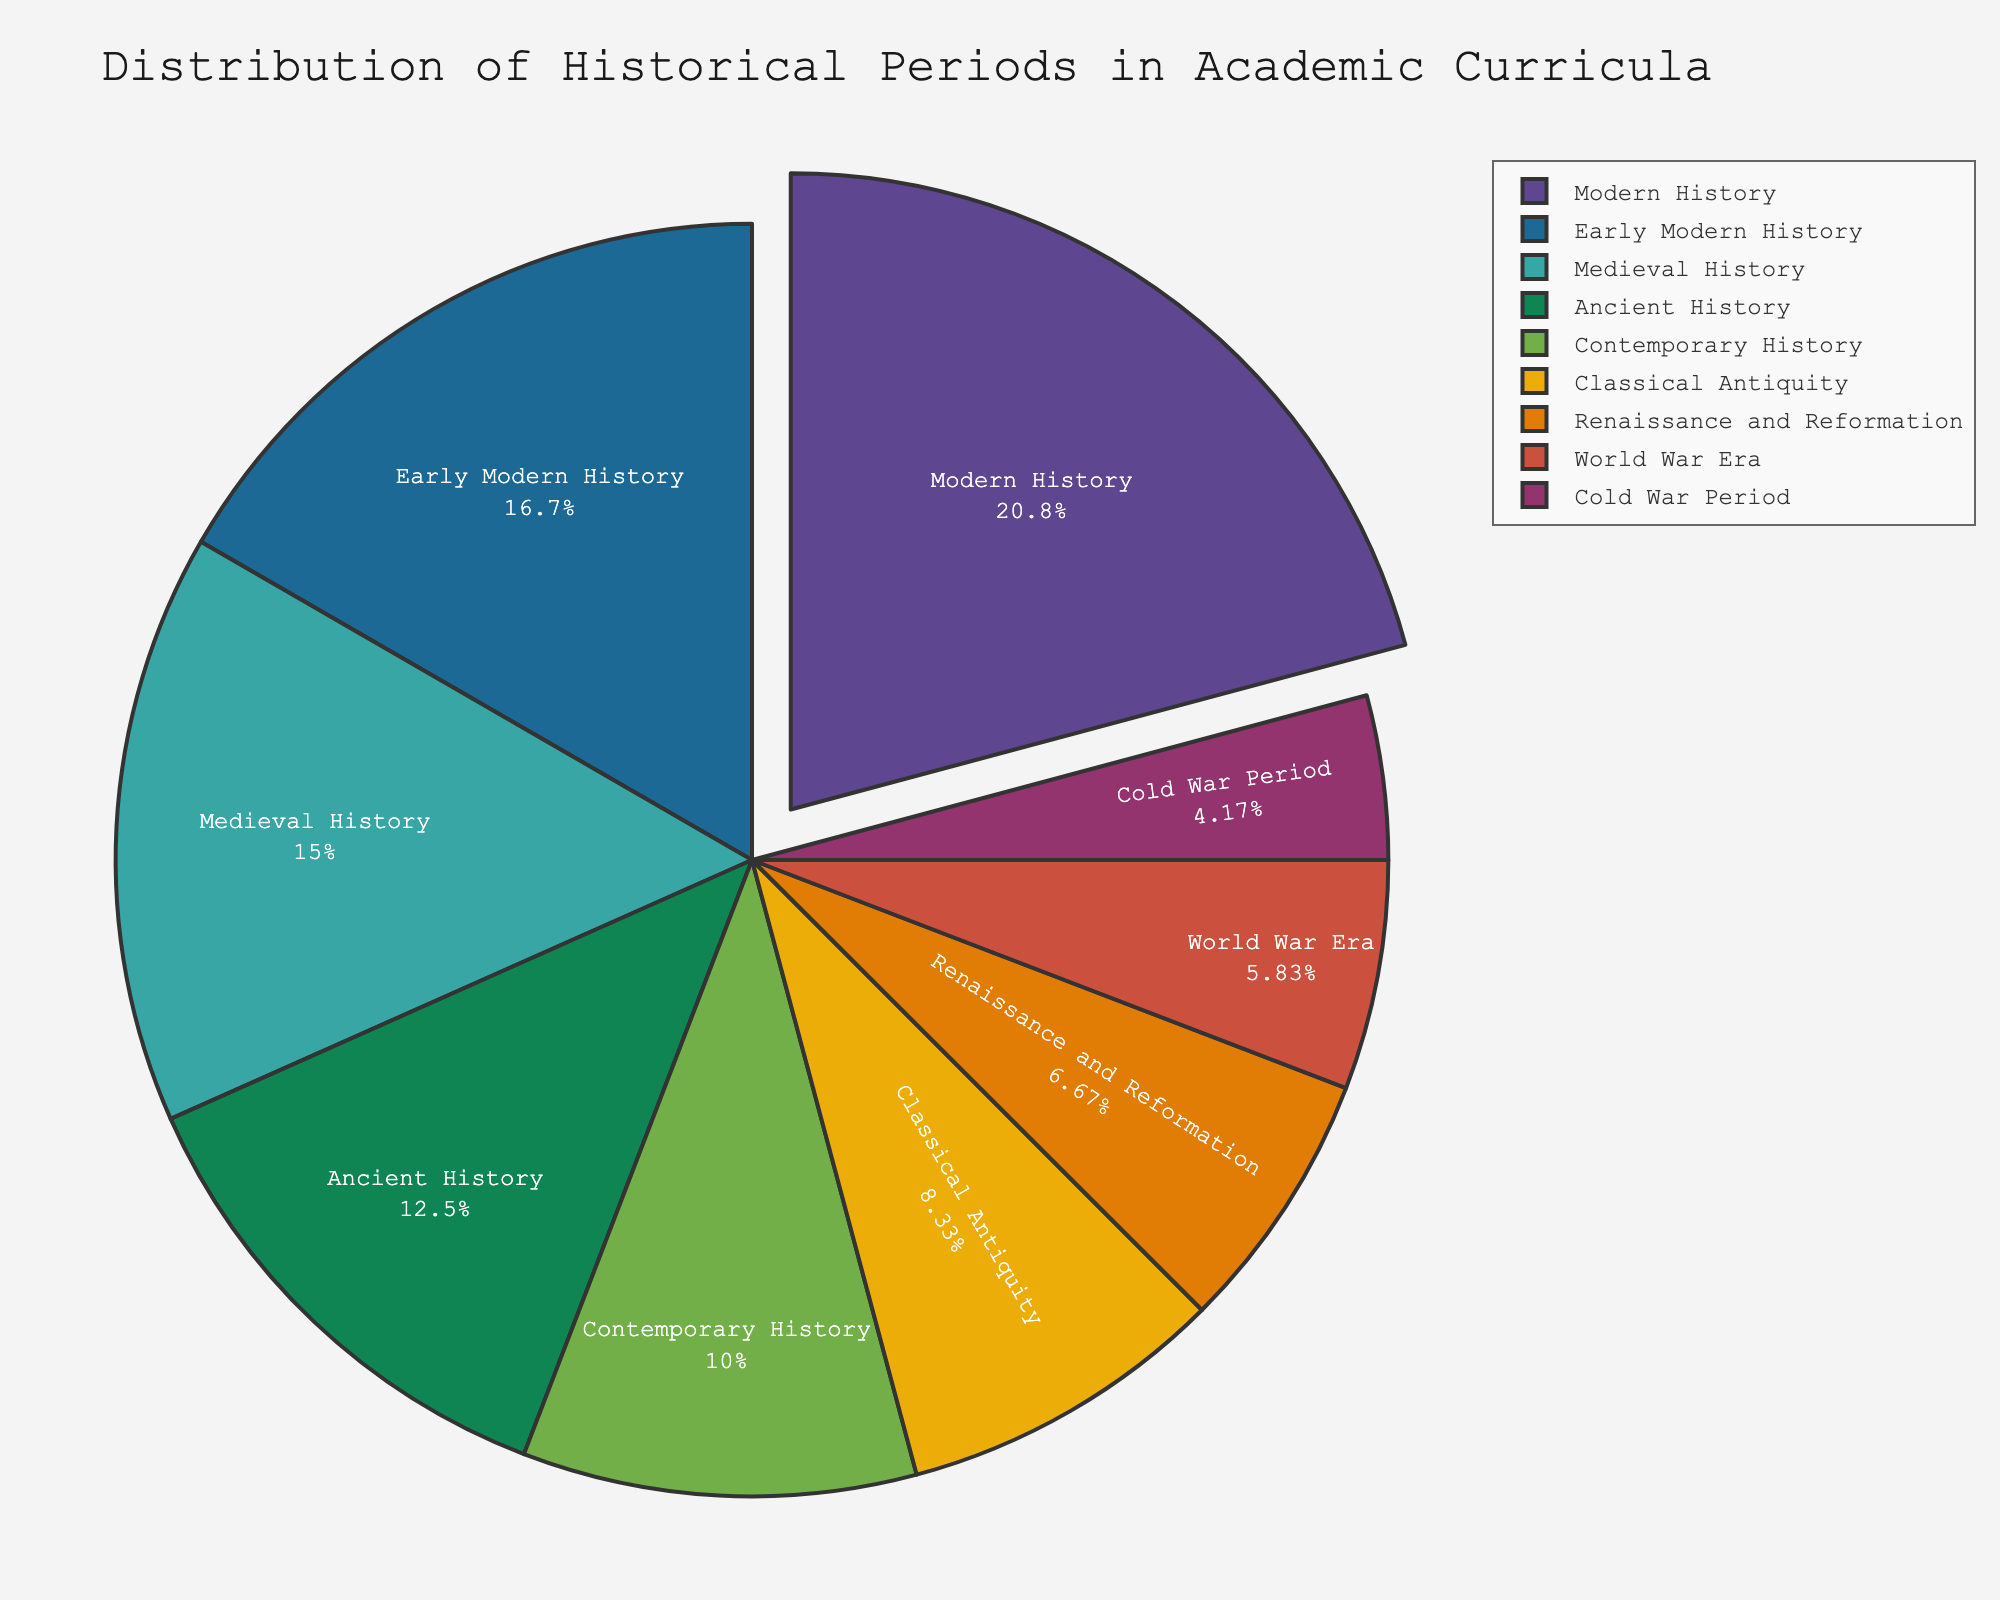What proportion of the historical periods is represented by Modern History? Modern History has a segment in the pie chart labeled with its percentage. Simply look at the label.
Answer: 25% Which historical period represents the smallest proportion in academic curricula, and what is its percentage? Find the smallest segment in the pie chart and refer to the label for its percentage.
Answer: Cold War Period, 5% How much more is the proportion of Ancient History compared to the Renaissance and Reformation? Look at the labels for Ancient History and Renaissance and Reformation to get their percentages and subtract the latter from the former (15% - 8%).
Answer: 7% What is the combined proportion of Medieval History and Early Modern History? Add the percentages of Medieval History and Early Modern History (18% + 20%).
Answer: 38% Which historical periods have a larger proportion than Classical Antiquity? Compare the percentage labels of Classical Antiquity (10%) to other periods. Ancient History (15%), Medieval History (18%), Early Modern History (20%), Modern History (25%), and Contemporary History (12%) have larger proportions.
Answer: Ancient History, Medieval History, Early Modern History, Modern History, Contemporary History How does the proportion of Contemporary History compare to that of Ancient History? Compare the percentage labels of Contemporary History (12%) to Ancient History (15%). Contemporary History is smaller.
Answer: Contemporary History is smaller What is the visual difference between the segment for World War Era and that of Cold War Period in the pie chart? The World War Era segment is slightly larger than the Cold War Period segment as represented by their respective percentages (7% vs. 5%).
Answer: World War Era is larger What is the total proportion represented by Modern History, Contemporary History, and the World War Era combined? Add the percentages of Modern History, Contemporary History, and the World War Era (25% + 12% + 7%).
Answer: 44% Are there more historical periods with proportions greater than or less than 10%? Count the periods with proportions greater than 10% and those with less. Greater than 10%: Ancient History (15%), Medieval History (18%), Early Modern History (20%), Modern History (25%), Contemporary History (12%)—total 5. Less than 10%: Classical Antiquity (10% which is not greater), Renaissance and Reformation (8%), World War Era (7%), Cold War Period (5%)—total 3.
Answer: More are greater than 10% What is the difference between the proportion of Early Modern History and the sum of the World War Era and the Cold War Period? Refer to the percentage labels: Early Modern History is 20%, World War Era is 7%, Cold War Period is 5%. Calculate the sum of World War Era and Cold War Period (7% + 5% = 12%), then subtract from Early Modern History (20% - 12%).
Answer: 8% 